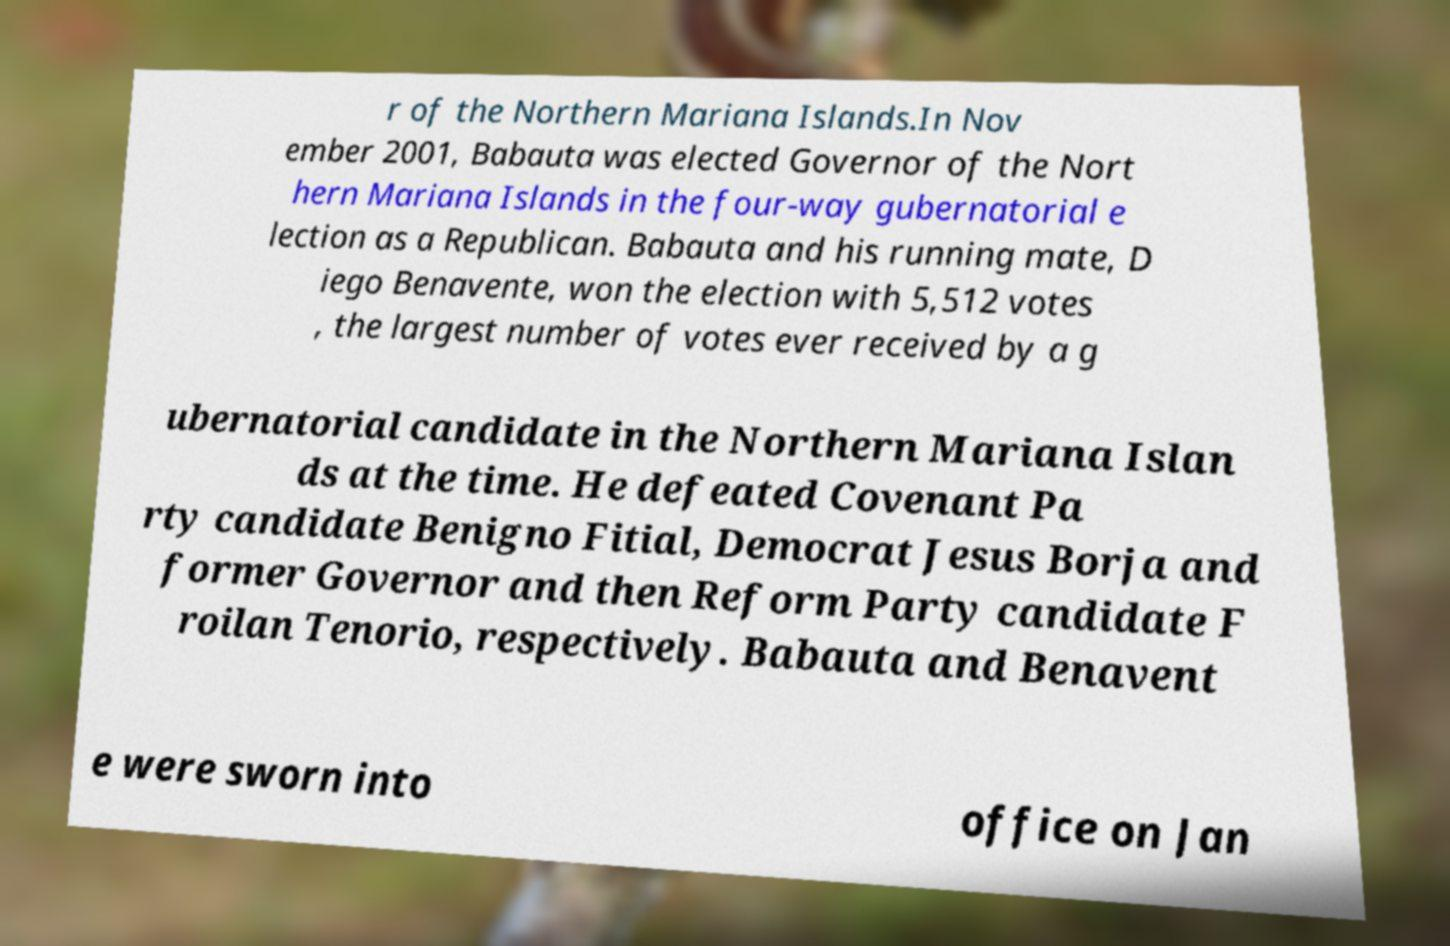Please read and relay the text visible in this image. What does it say? r of the Northern Mariana Islands.In Nov ember 2001, Babauta was elected Governor of the Nort hern Mariana Islands in the four-way gubernatorial e lection as a Republican. Babauta and his running mate, D iego Benavente, won the election with 5,512 votes , the largest number of votes ever received by a g ubernatorial candidate in the Northern Mariana Islan ds at the time. He defeated Covenant Pa rty candidate Benigno Fitial, Democrat Jesus Borja and former Governor and then Reform Party candidate F roilan Tenorio, respectively. Babauta and Benavent e were sworn into office on Jan 